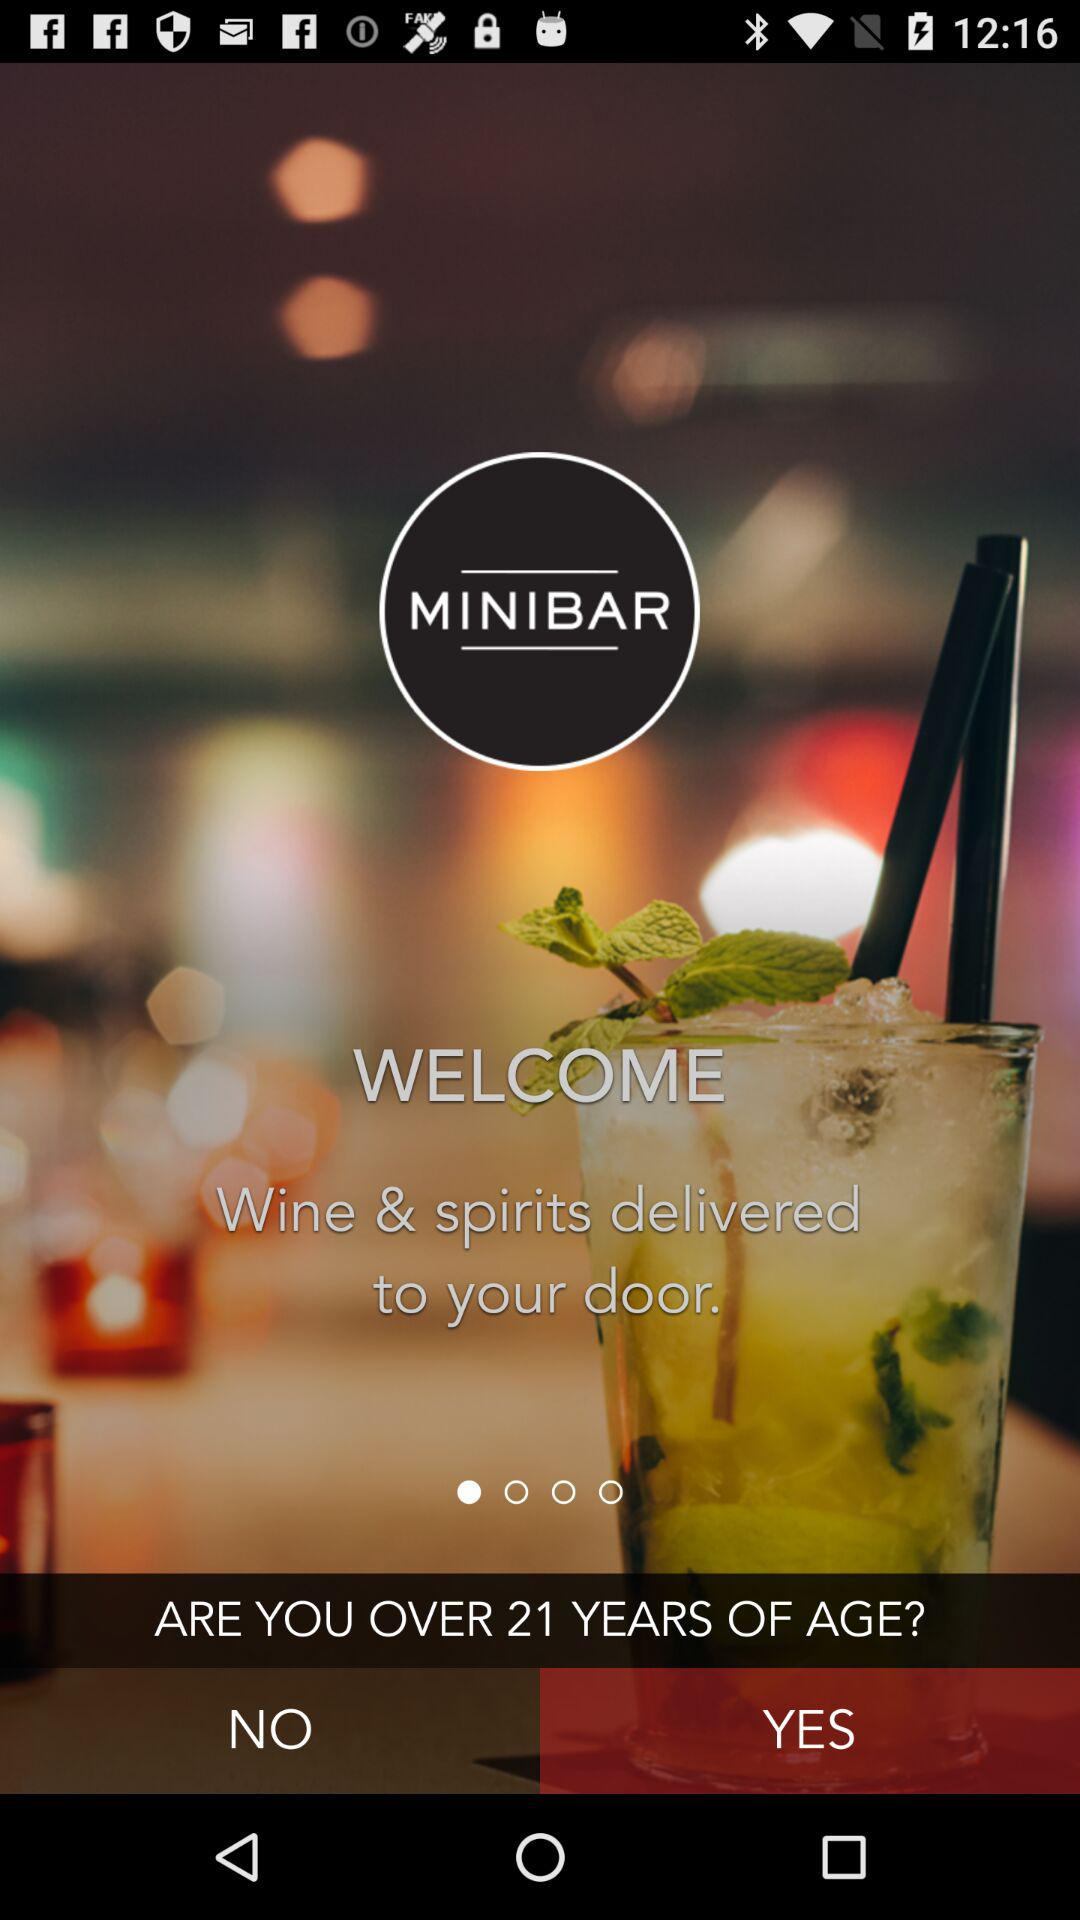Which tab is selected currently for age?
When the provided information is insufficient, respond with <no answer>. <no answer> 